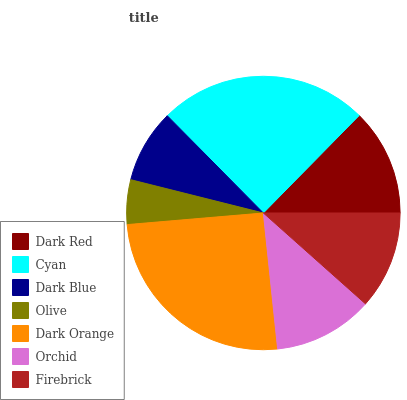Is Olive the minimum?
Answer yes or no. Yes. Is Dark Orange the maximum?
Answer yes or no. Yes. Is Cyan the minimum?
Answer yes or no. No. Is Cyan the maximum?
Answer yes or no. No. Is Cyan greater than Dark Red?
Answer yes or no. Yes. Is Dark Red less than Cyan?
Answer yes or no. Yes. Is Dark Red greater than Cyan?
Answer yes or no. No. Is Cyan less than Dark Red?
Answer yes or no. No. Is Orchid the high median?
Answer yes or no. Yes. Is Orchid the low median?
Answer yes or no. Yes. Is Cyan the high median?
Answer yes or no. No. Is Dark Orange the low median?
Answer yes or no. No. 